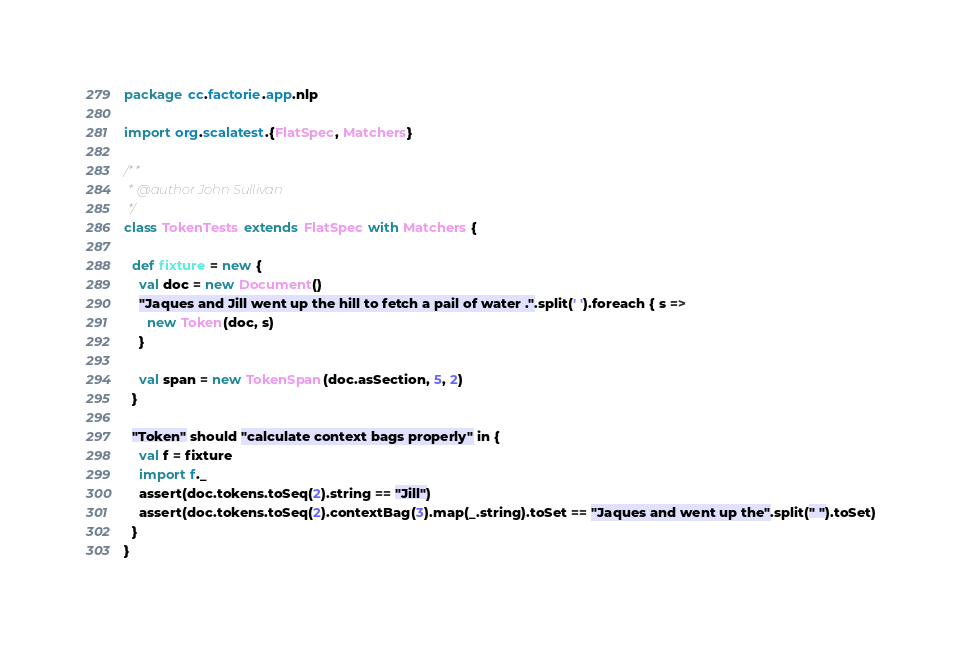Convert code to text. <code><loc_0><loc_0><loc_500><loc_500><_Scala_>package cc.factorie.app.nlp

import org.scalatest.{FlatSpec, Matchers}

/**
 * @author John Sullivan
 */
class TokenTests extends FlatSpec with Matchers {

  def fixture = new {
    val doc = new Document()
    "Jaques and Jill went up the hill to fetch a pail of water .".split(' ').foreach { s =>
      new Token(doc, s)
    }

    val span = new TokenSpan(doc.asSection, 5, 2)
  }

  "Token" should "calculate context bags properly" in {
    val f = fixture
    import f._
    assert(doc.tokens.toSeq(2).string == "Jill")
    assert(doc.tokens.toSeq(2).contextBag(3).map(_.string).toSet == "Jaques and went up the".split(" ").toSet)
  }
}
</code> 